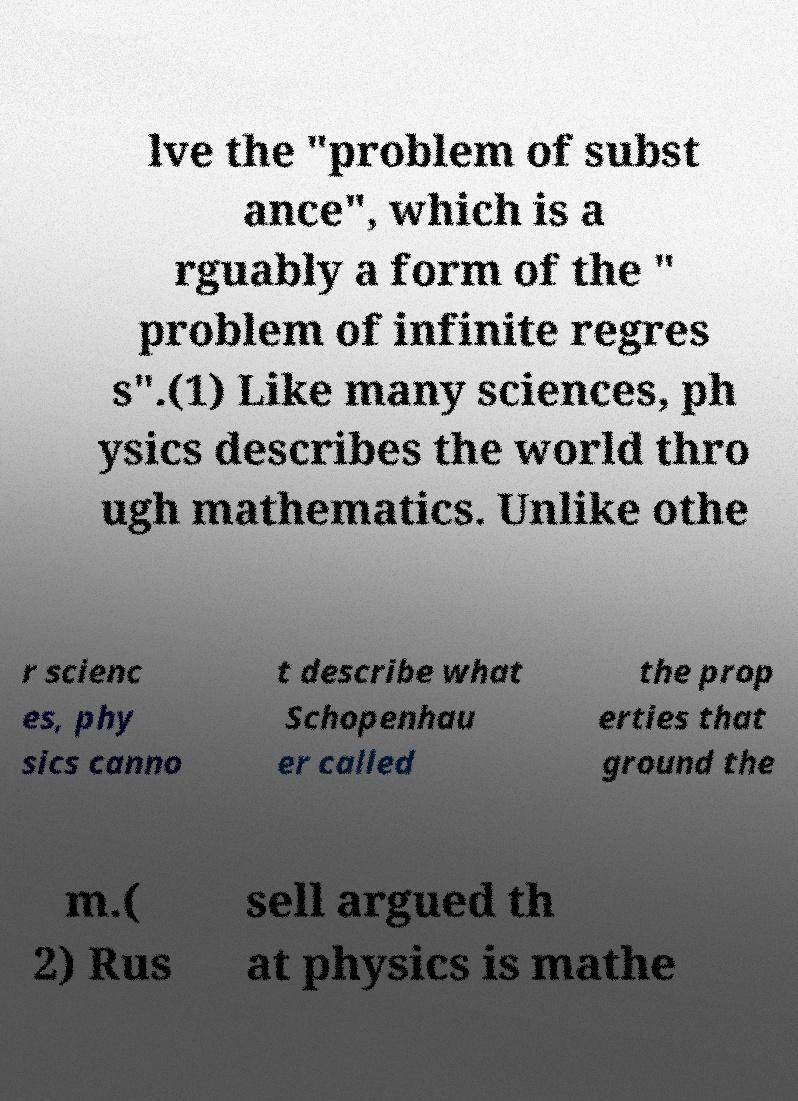There's text embedded in this image that I need extracted. Can you transcribe it verbatim? lve the "problem of subst ance", which is a rguably a form of the " problem of infinite regres s".(1) Like many sciences, ph ysics describes the world thro ugh mathematics. Unlike othe r scienc es, phy sics canno t describe what Schopenhau er called the prop erties that ground the m.( 2) Rus sell argued th at physics is mathe 